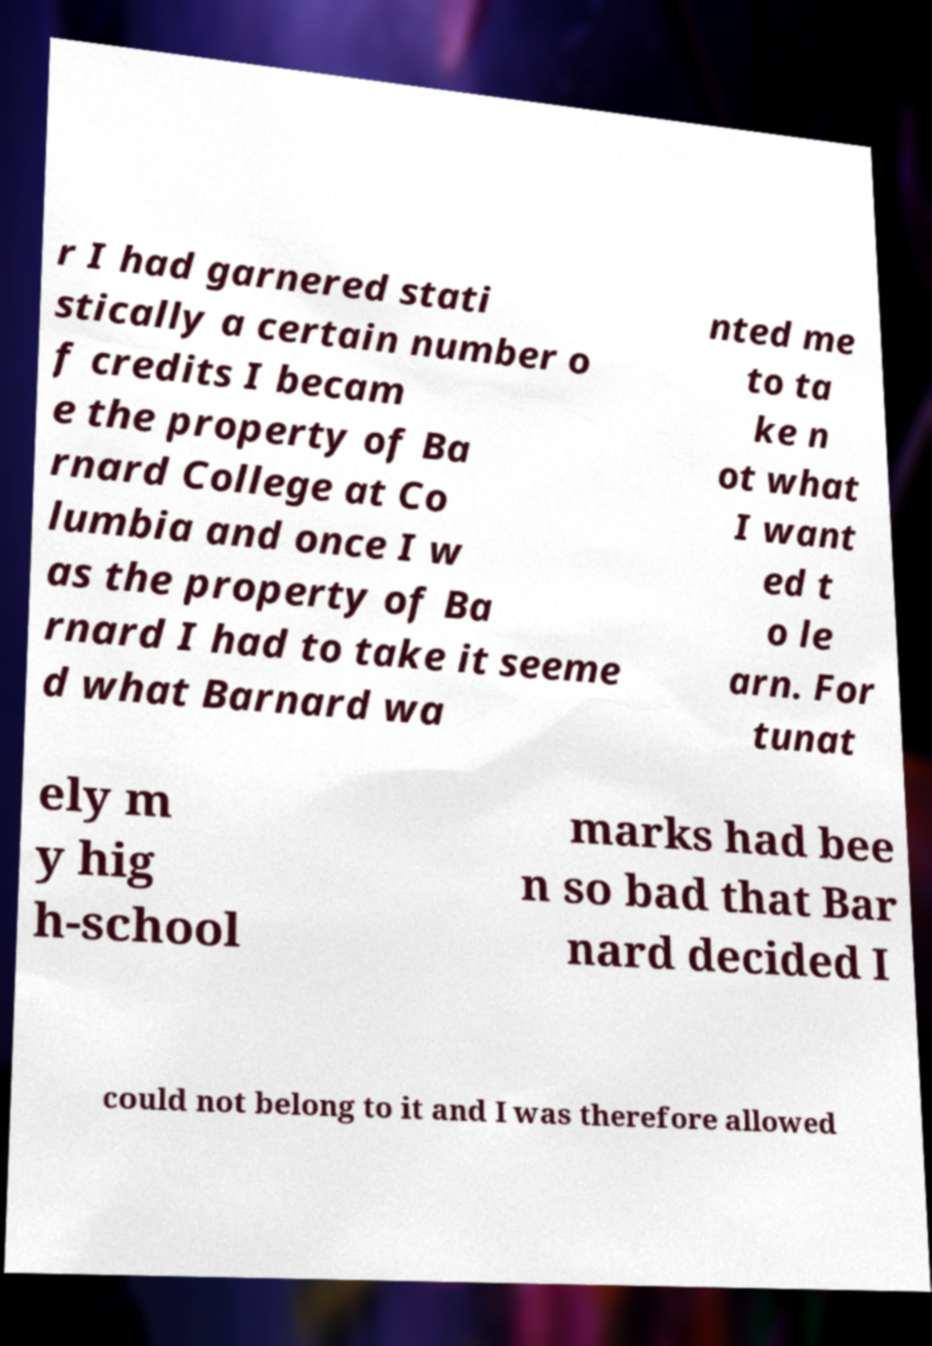I need the written content from this picture converted into text. Can you do that? r I had garnered stati stically a certain number o f credits I becam e the property of Ba rnard College at Co lumbia and once I w as the property of Ba rnard I had to take it seeme d what Barnard wa nted me to ta ke n ot what I want ed t o le arn. For tunat ely m y hig h-school marks had bee n so bad that Bar nard decided I could not belong to it and I was therefore allowed 